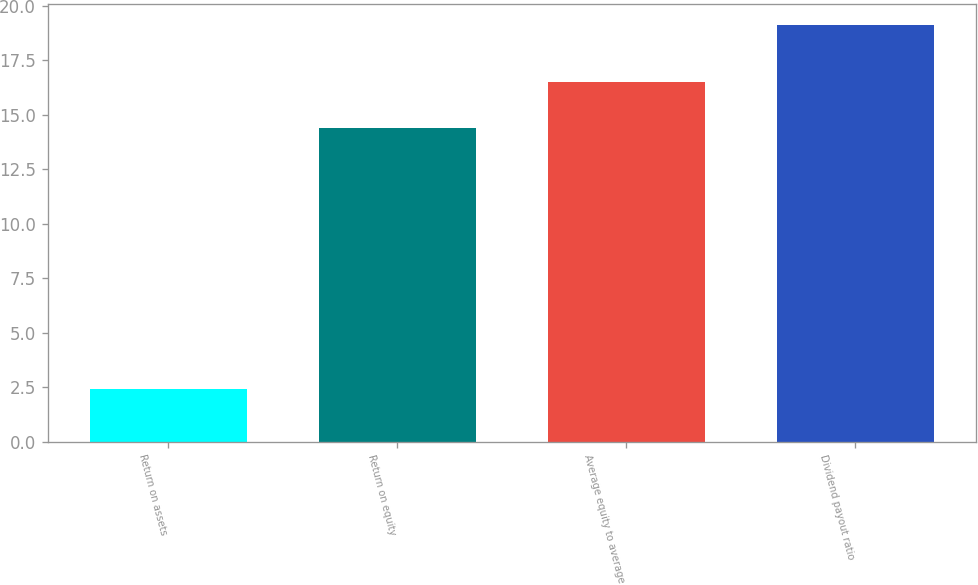<chart> <loc_0><loc_0><loc_500><loc_500><bar_chart><fcel>Return on assets<fcel>Return on equity<fcel>Average equity to average<fcel>Dividend payout ratio<nl><fcel>2.4<fcel>14.4<fcel>16.5<fcel>19.1<nl></chart> 